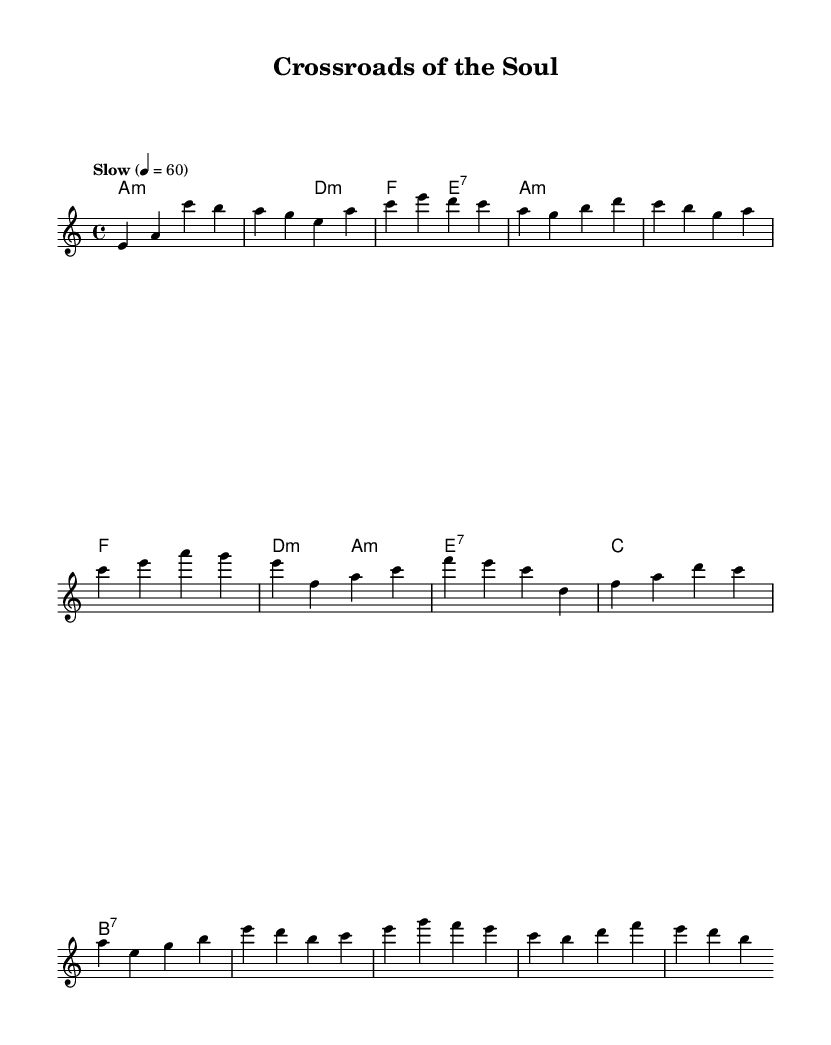What is the key signature of this music? The key signature is A minor, which includes no sharps or flats. This is indicated at the beginning of the score where the key signature is shown.
Answer: A minor What is the time signature of this music? The time signature is 4/4, as indicated at the start of the score. This means there are four beats in each measure and a quarter note gets one beat.
Answer: 4/4 What is the tempo marking of this music? The tempo marking is "Slow," and it specifies that the piece should be played at a speed of 60 beats per minute. This provides the performer with guidance on how quickly to play the piece.
Answer: Slow How many measures are in the verse section? There are 6 measures in the verse section as noted in the melody line from the measures provided. Counting each distinct grouping of notes shows this total in the given melody.
Answer: 6 What type of chords are predominantly used in this piece? The predominant chords are minor and dominant seventh chords, common in blues music. This can be determined by analyzing the chord labels given in the harmonies section.
Answer: Minor and dominant seventh What is the structure of the song based on the sections provided? The song has a structure that includes an intro, several verses, a chorus, and a bridge. This structure is typical for blues music, which often features repeated verses and a strong thematic message.
Answer: Intro, verse, chorus, bridge What does the refrain melody focus on emotionally? The refrain melody evokes themes of struggle and moral questioning, common in blues music. Analysis of the melody and harmony indicates an emotional depth aimed at reflecting personal trials and seeking resolution.
Answer: Struggle and moral questioning 